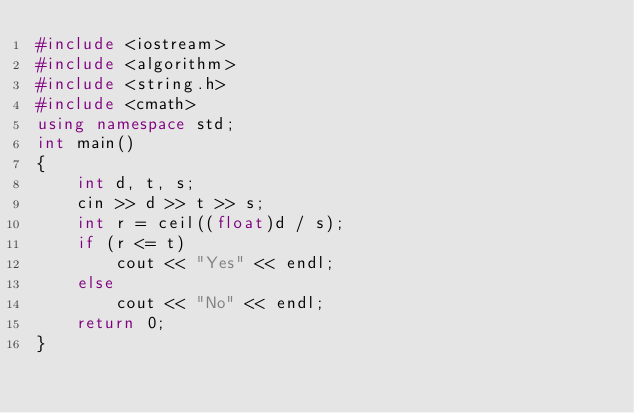<code> <loc_0><loc_0><loc_500><loc_500><_C++_>#include <iostream>
#include <algorithm>
#include <string.h>
#include <cmath>
using namespace std;
int main()
{
    int d, t, s;
    cin >> d >> t >> s;
    int r = ceil((float)d / s);
    if (r <= t)
        cout << "Yes" << endl;
    else
        cout << "No" << endl;
    return 0;
}</code> 